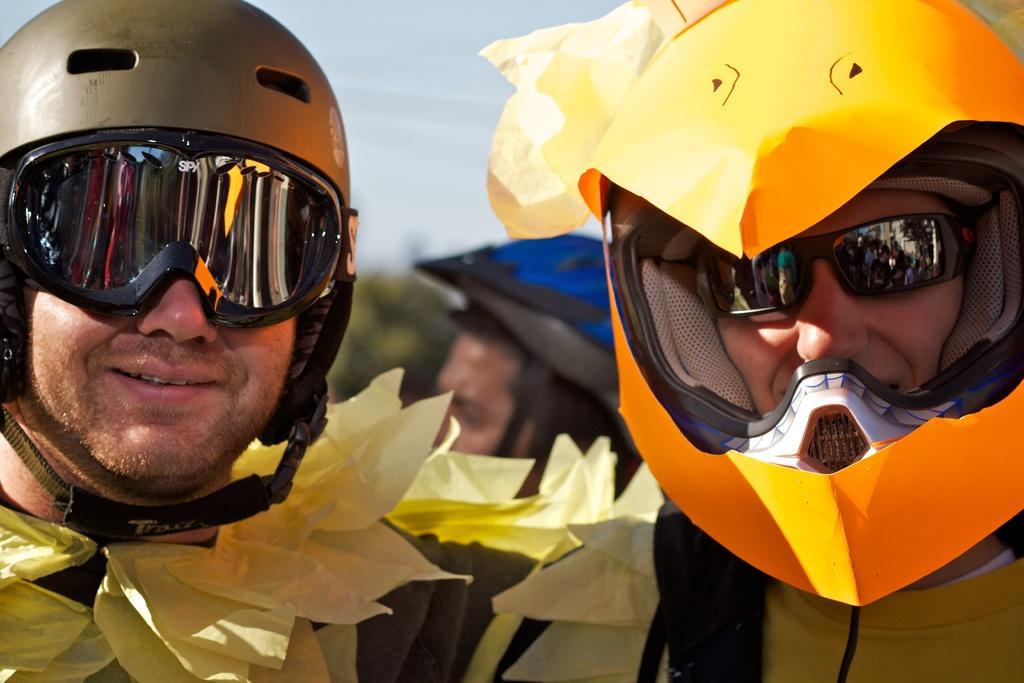In one or two sentences, can you explain what this image depicts? In this picture we can see three persons, they are wearing helmets, we can see the sky at the top of the picture, there is a blurry background. 